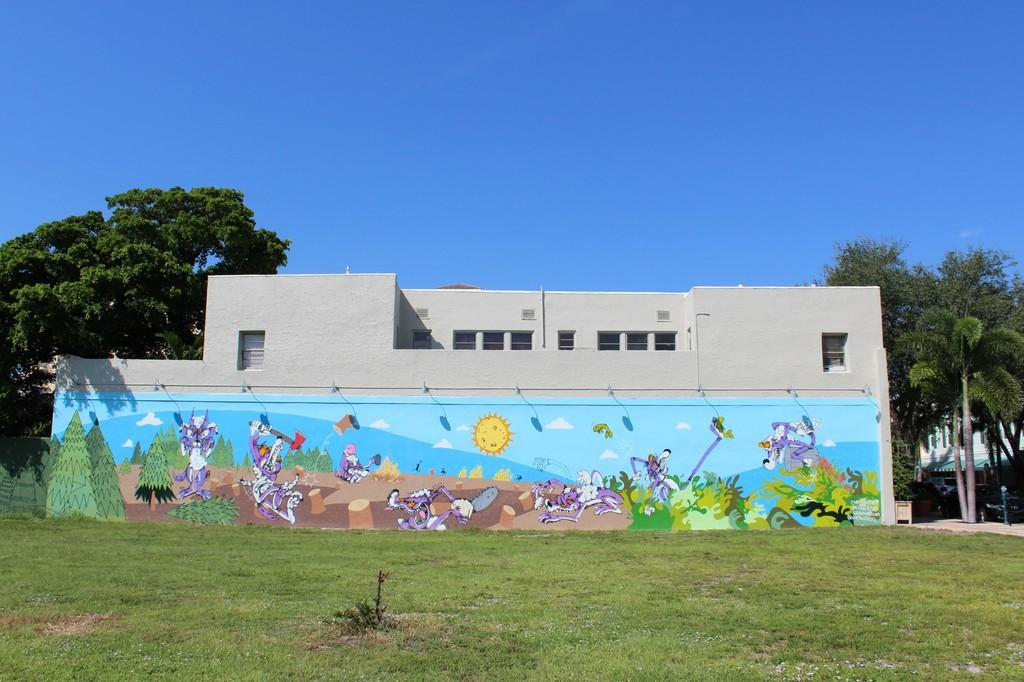What is the main subject in the center of the image? There is a house in the center of the image. What can be seen on the wall inside the house? There is a painting on the wall. What type of vegetation is visible at the bottom of the image? There is grass at the bottom of the image. What can be seen in the background of the image? There are trees and the sky visible in the background. What type of nail design can be seen on the house in the image? There is no nail design visible on the house in the image; it is a regular house with no specific design elements mentioned. 